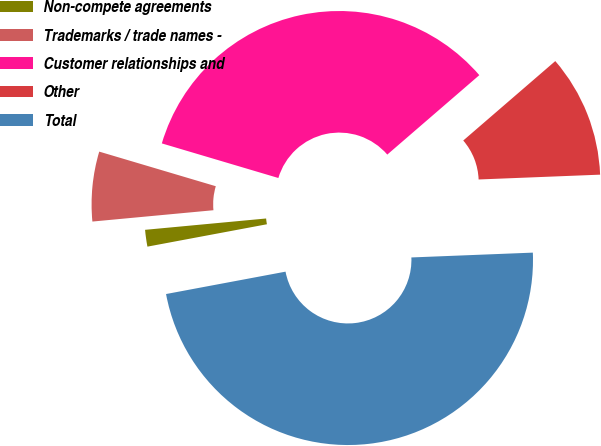Convert chart to OTSL. <chart><loc_0><loc_0><loc_500><loc_500><pie_chart><fcel>Non-compete agreements<fcel>Trademarks / trade names -<fcel>Customer relationships and<fcel>Other<fcel>Total<nl><fcel>1.46%<fcel>6.08%<fcel>34.07%<fcel>10.7%<fcel>47.68%<nl></chart> 